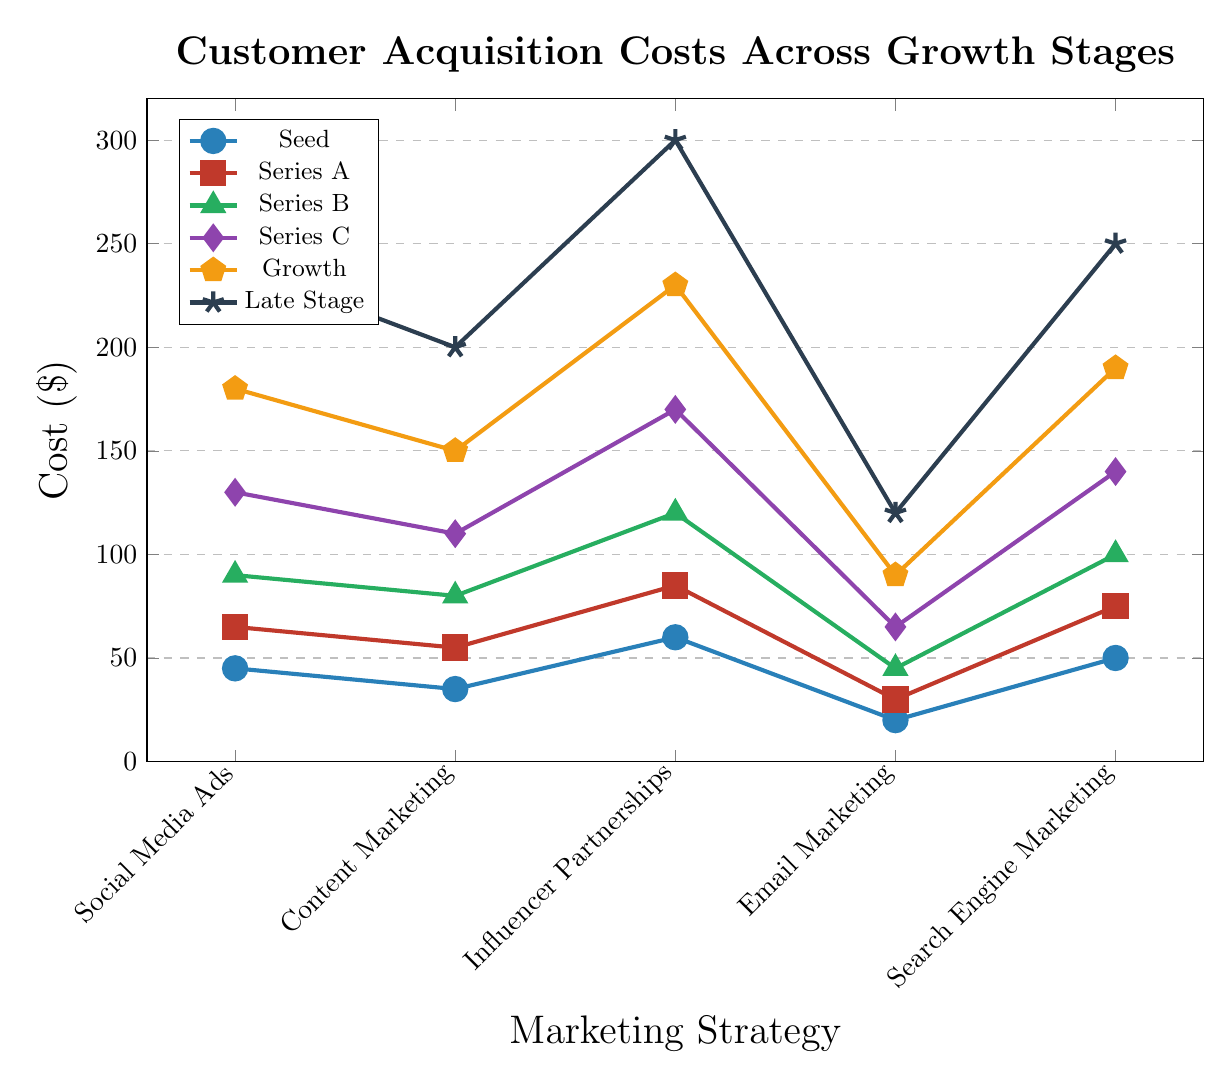What is the customer acquisition cost for Email Marketing at the Series C stage? To find this, look at the Email Marketing row for the Series C stage. The cost is listed as $65.
Answer: $65 Which marketing strategy has the lowest customer acquisition cost at the Seed stage? Compare the costs of all marketing strategies at the Seed stage. The costs are: Social Media Ads ($45), Content Marketing ($35), Influencer Partnerships ($60), Email Marketing ($20), and Search Engine Marketing ($50). The lowest cost is $20 for Email Marketing.
Answer: Email Marketing How does the cost of Search Engine Marketing change from Series A to Growth stages? Look at the costs of Search Engine Marketing at Series A and Growth stages. Series A has $75 and Growth has $190. The difference is $190 - $75 = $115.
Answer: It increases by $115 Which stage shows the highest cost for Influencer Partnerships and what is that cost? Examine the cost across all stages for Influencer Partnerships. The costs are: Seed ($60), Series A ($85), Series B ($120), Series C ($170), Growth ($230), Late Stage ($300). The highest cost is $300 at Late Stage.
Answer: Late Stage, $300 What’s the average customer acquisition cost for Content Marketing across all stages? Add up the costs for all stages for Content Marketing and divide by the number of stages. The costs are: Seed ($35), Series A ($55), Series B ($80), Series C ($110), Growth ($150), Late Stage ($200). Sum is $35 + $55 + $80 + $110 + $150 + $200 = $630. Average is $630 / 6 = $105.
Answer: $105 Which marketing strategy experiences the highest increase in customer acquisition cost from Seed to Late Stage? Calculate the increase in cost from Seed to Late Stage for each strategy: Social Media Ads: $240 - $45 = $195, Content Marketing: $200 - $35 = $165, Influencer Partnerships: $300 - $60 = $240, Email Marketing: $120 - $20 = $100, Search Engine Marketing: $250 - $50 = $200. The highest increase is $240 for Influencer Partnerships.
Answer: Influencer Partnerships Compare the customer acquisition costs for Social Media Ads and Content Marketing at Growth stage. Which one is higher and by how much? For Growth stage, Social Media Ads cost $180 and Content Marketing costs $150. The difference is $180 - $150 = $30. Social Media Ads is higher by $30.
Answer: Social Media Ads, $30 higher What is the trend of customer acquisition cost for Email Marketing as the startup grows from Seed to Late Stage? Observe the cost for Email Marketing across the stages: Seed ($20), Series A ($30), Series B ($45), Series C ($65), Growth ($90), Late Stage ($120). The cost gradually increases as the startup grows.
Answer: Gradually increases 